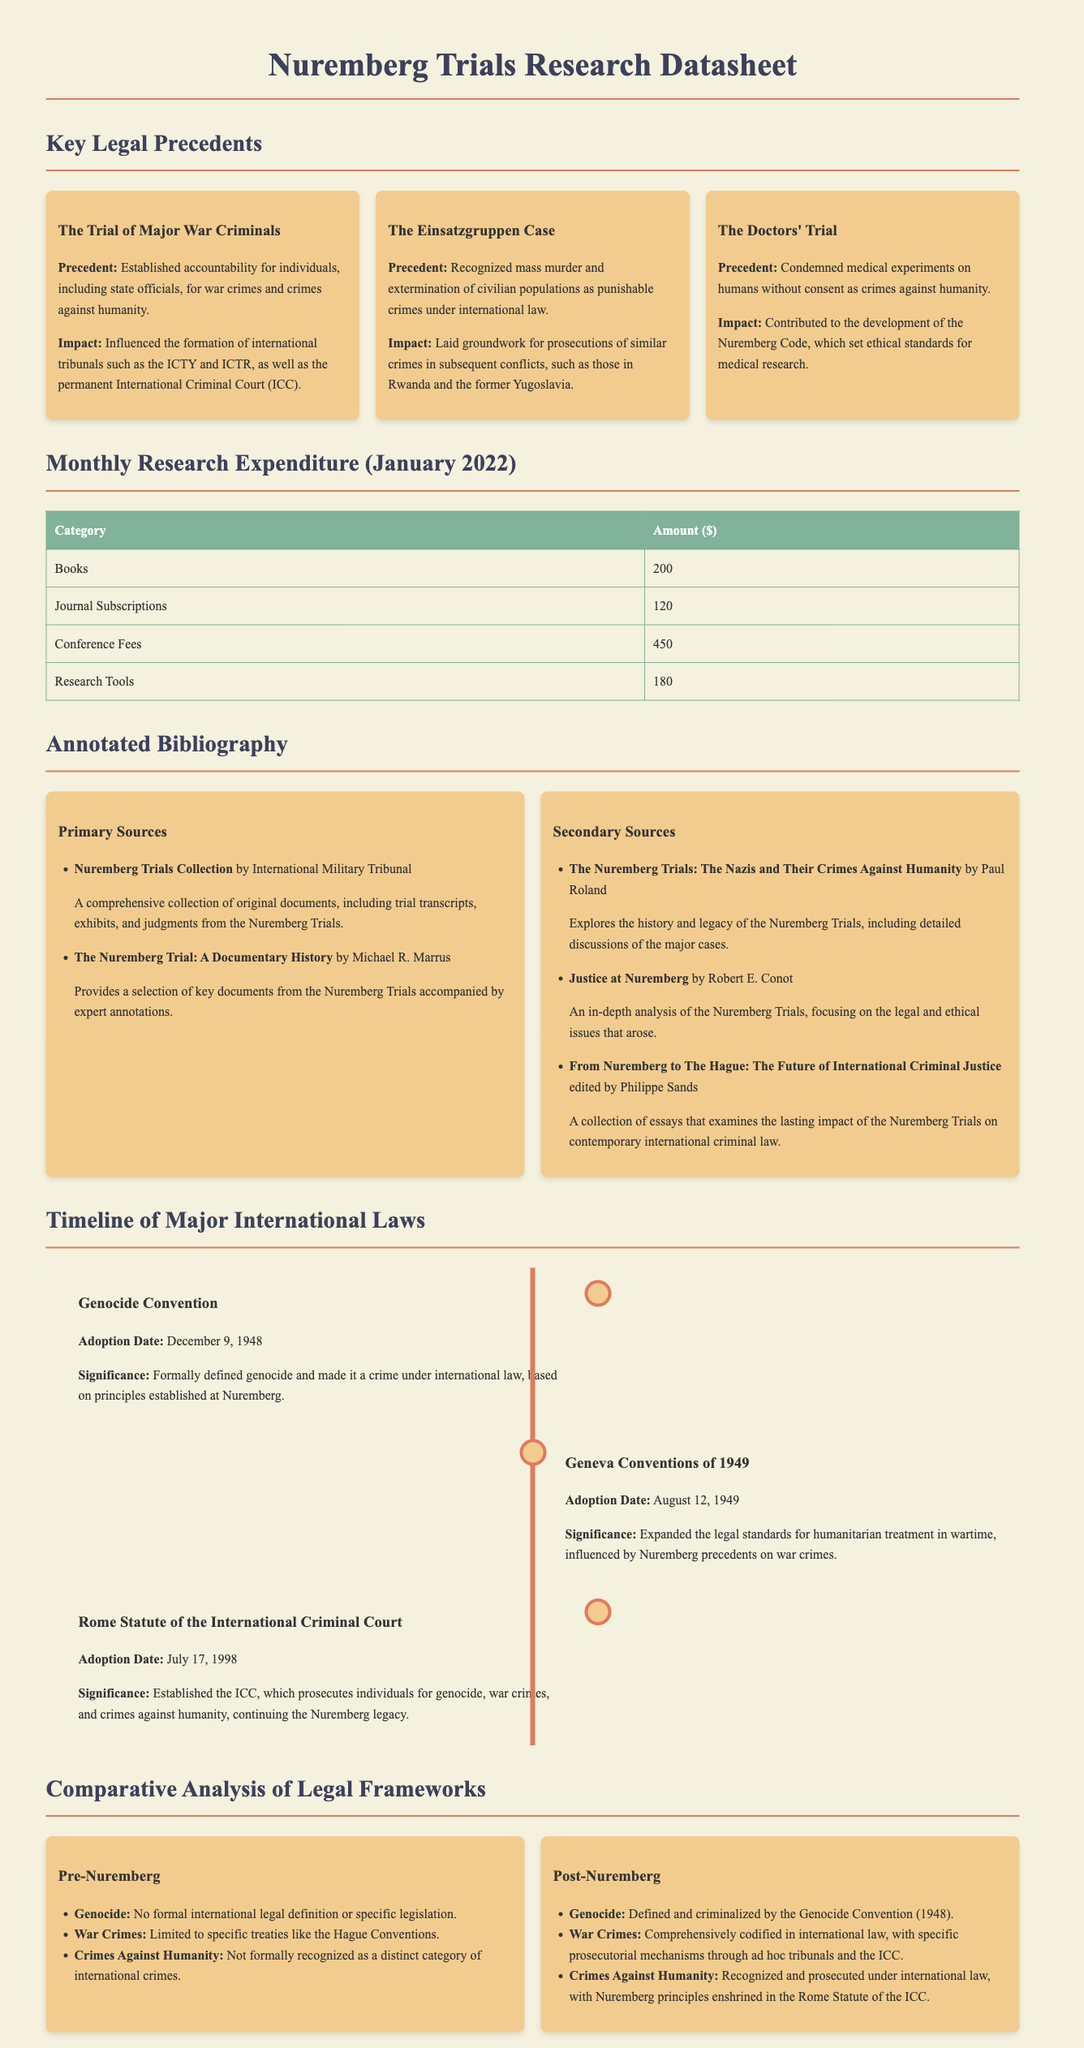What is the title of the document? The title mentioned in the document is prominently displayed at the top.
Answer: Nuremberg Trials Research Datasheet Who was the author of the "Doctors' Trial"? The document mentions specific trials but does not provide the authors; however, it refers to the trials of Nazi doctors.
Answer: The Doctors' Trial What is the total amount spent on conference fees in January 2022? The table specifies the amount allocated for conference fees in the monthly research expenditure section.
Answer: 450 What was the adoption date of the Genocide Convention? The timeline section states the adoption date for the Genocide Convention explicitly.
Answer: December 9, 1948 What significant legal principle was established by the Einsatzgruppen Case? The document summarizes key legal precedents and identifies the principle related to mass murder and extermination of civilian populations.
Answer: Punishable crimes under international law How much was spent on books in January 2022? The table details the costs for various categories, including the amount allocated for books.
Answer: 200 What is one major change in international law post-Nuremberg for genocide? The comparative analysis highlights changes introduced after the Nuremberg Trials concerning genocide laws.
Answer: Defined and criminalized What is the significance of the Rome Statute of the International Criminal Court? The timeline provides information about the significance of this statute in relation to previous Nuremberg principles.
Answer: Established the ICC How many primary sources are listed in the annotated bibliography? The document provides a list of primary sources under the respective section.
Answer: 2 